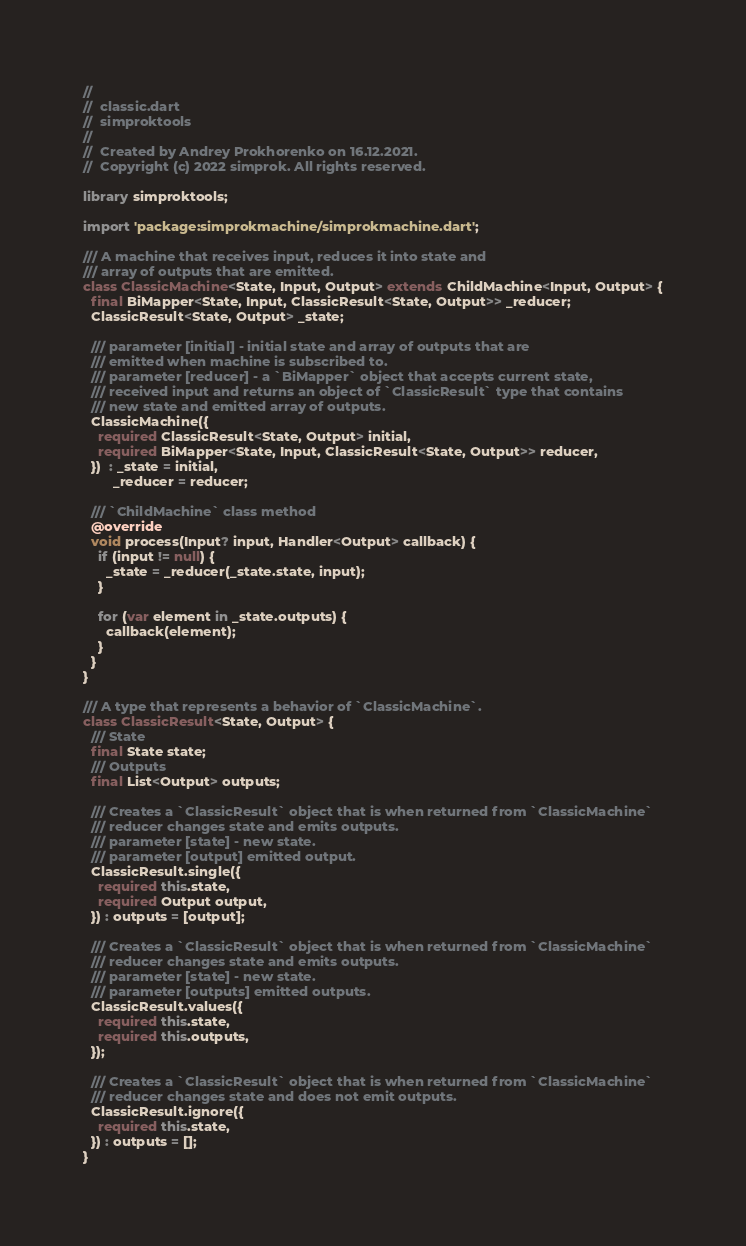Convert code to text. <code><loc_0><loc_0><loc_500><loc_500><_Dart_>//
//  classic.dart
//  simproktools
//
//  Created by Andrey Prokhorenko on 16.12.2021.
//  Copyright (c) 2022 simprok. All rights reserved.

library simproktools;

import 'package:simprokmachine/simprokmachine.dart';

/// A machine that receives input, reduces it into state and
/// array of outputs that are emitted.
class ClassicMachine<State, Input, Output> extends ChildMachine<Input, Output> {
  final BiMapper<State, Input, ClassicResult<State, Output>> _reducer;
  ClassicResult<State, Output> _state;

  /// parameter [initial] - initial state and array of outputs that are
  /// emitted when machine is subscribed to.
  /// parameter [reducer] - a `BiMapper` object that accepts current state,
  /// received input and returns an object of `ClassicResult` type that contains
  /// new state and emitted array of outputs.
  ClassicMachine({
    required ClassicResult<State, Output> initial,
    required BiMapper<State, Input, ClassicResult<State, Output>> reducer,
  })  : _state = initial,
        _reducer = reducer;

  /// `ChildMachine` class method
  @override
  void process(Input? input, Handler<Output> callback) {
    if (input != null) {
      _state = _reducer(_state.state, input);
    }

    for (var element in _state.outputs) {
      callback(element);
    }
  }
}

/// A type that represents a behavior of `ClassicMachine`.
class ClassicResult<State, Output> {
  /// State
  final State state;
  /// Outputs
  final List<Output> outputs;

  /// Creates a `ClassicResult` object that is when returned from `ClassicMachine`
  /// reducer changes state and emits outputs.
  /// parameter [state] - new state.
  /// parameter [output] emitted output.
  ClassicResult.single({
    required this.state,
    required Output output,
  }) : outputs = [output];

  /// Creates a `ClassicResult` object that is when returned from `ClassicMachine`
  /// reducer changes state and emits outputs.
  /// parameter [state] - new state.
  /// parameter [outputs] emitted outputs.
  ClassicResult.values({
    required this.state,
    required this.outputs,
  });

  /// Creates a `ClassicResult` object that is when returned from `ClassicMachine`
  /// reducer changes state and does not emit outputs.
  ClassicResult.ignore({
    required this.state,
  }) : outputs = [];
}
</code> 